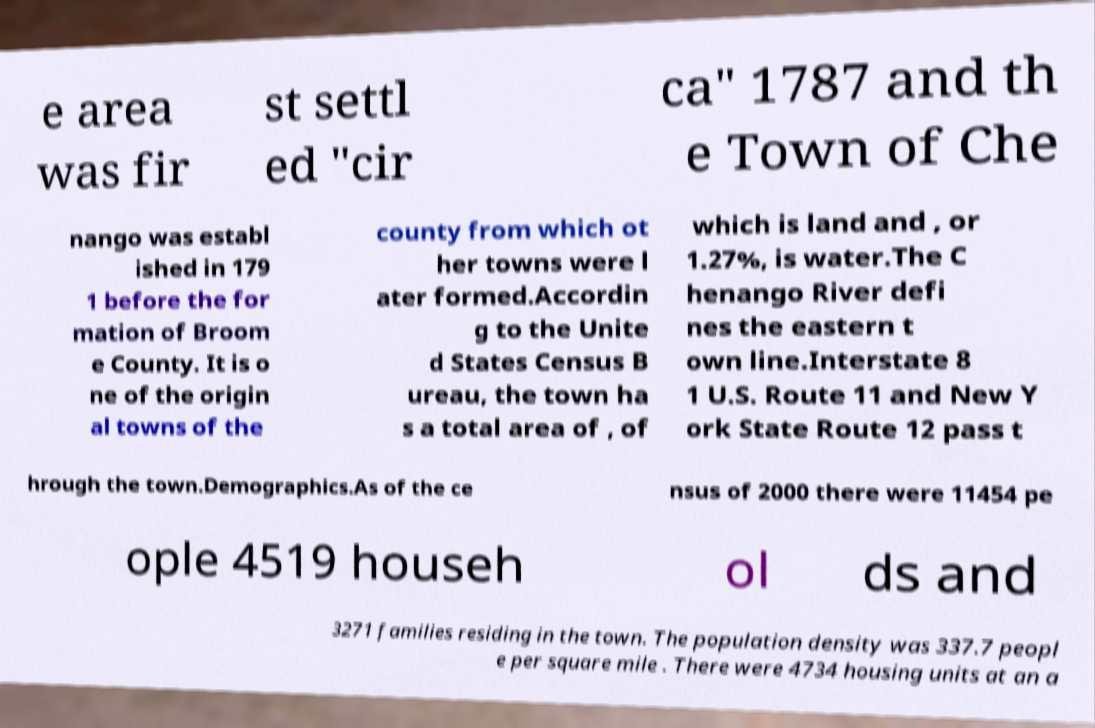Can you accurately transcribe the text from the provided image for me? e area was fir st settl ed "cir ca" 1787 and th e Town of Che nango was establ ished in 179 1 before the for mation of Broom e County. It is o ne of the origin al towns of the county from which ot her towns were l ater formed.Accordin g to the Unite d States Census B ureau, the town ha s a total area of , of which is land and , or 1.27%, is water.The C henango River defi nes the eastern t own line.Interstate 8 1 U.S. Route 11 and New Y ork State Route 12 pass t hrough the town.Demographics.As of the ce nsus of 2000 there were 11454 pe ople 4519 househ ol ds and 3271 families residing in the town. The population density was 337.7 peopl e per square mile . There were 4734 housing units at an a 